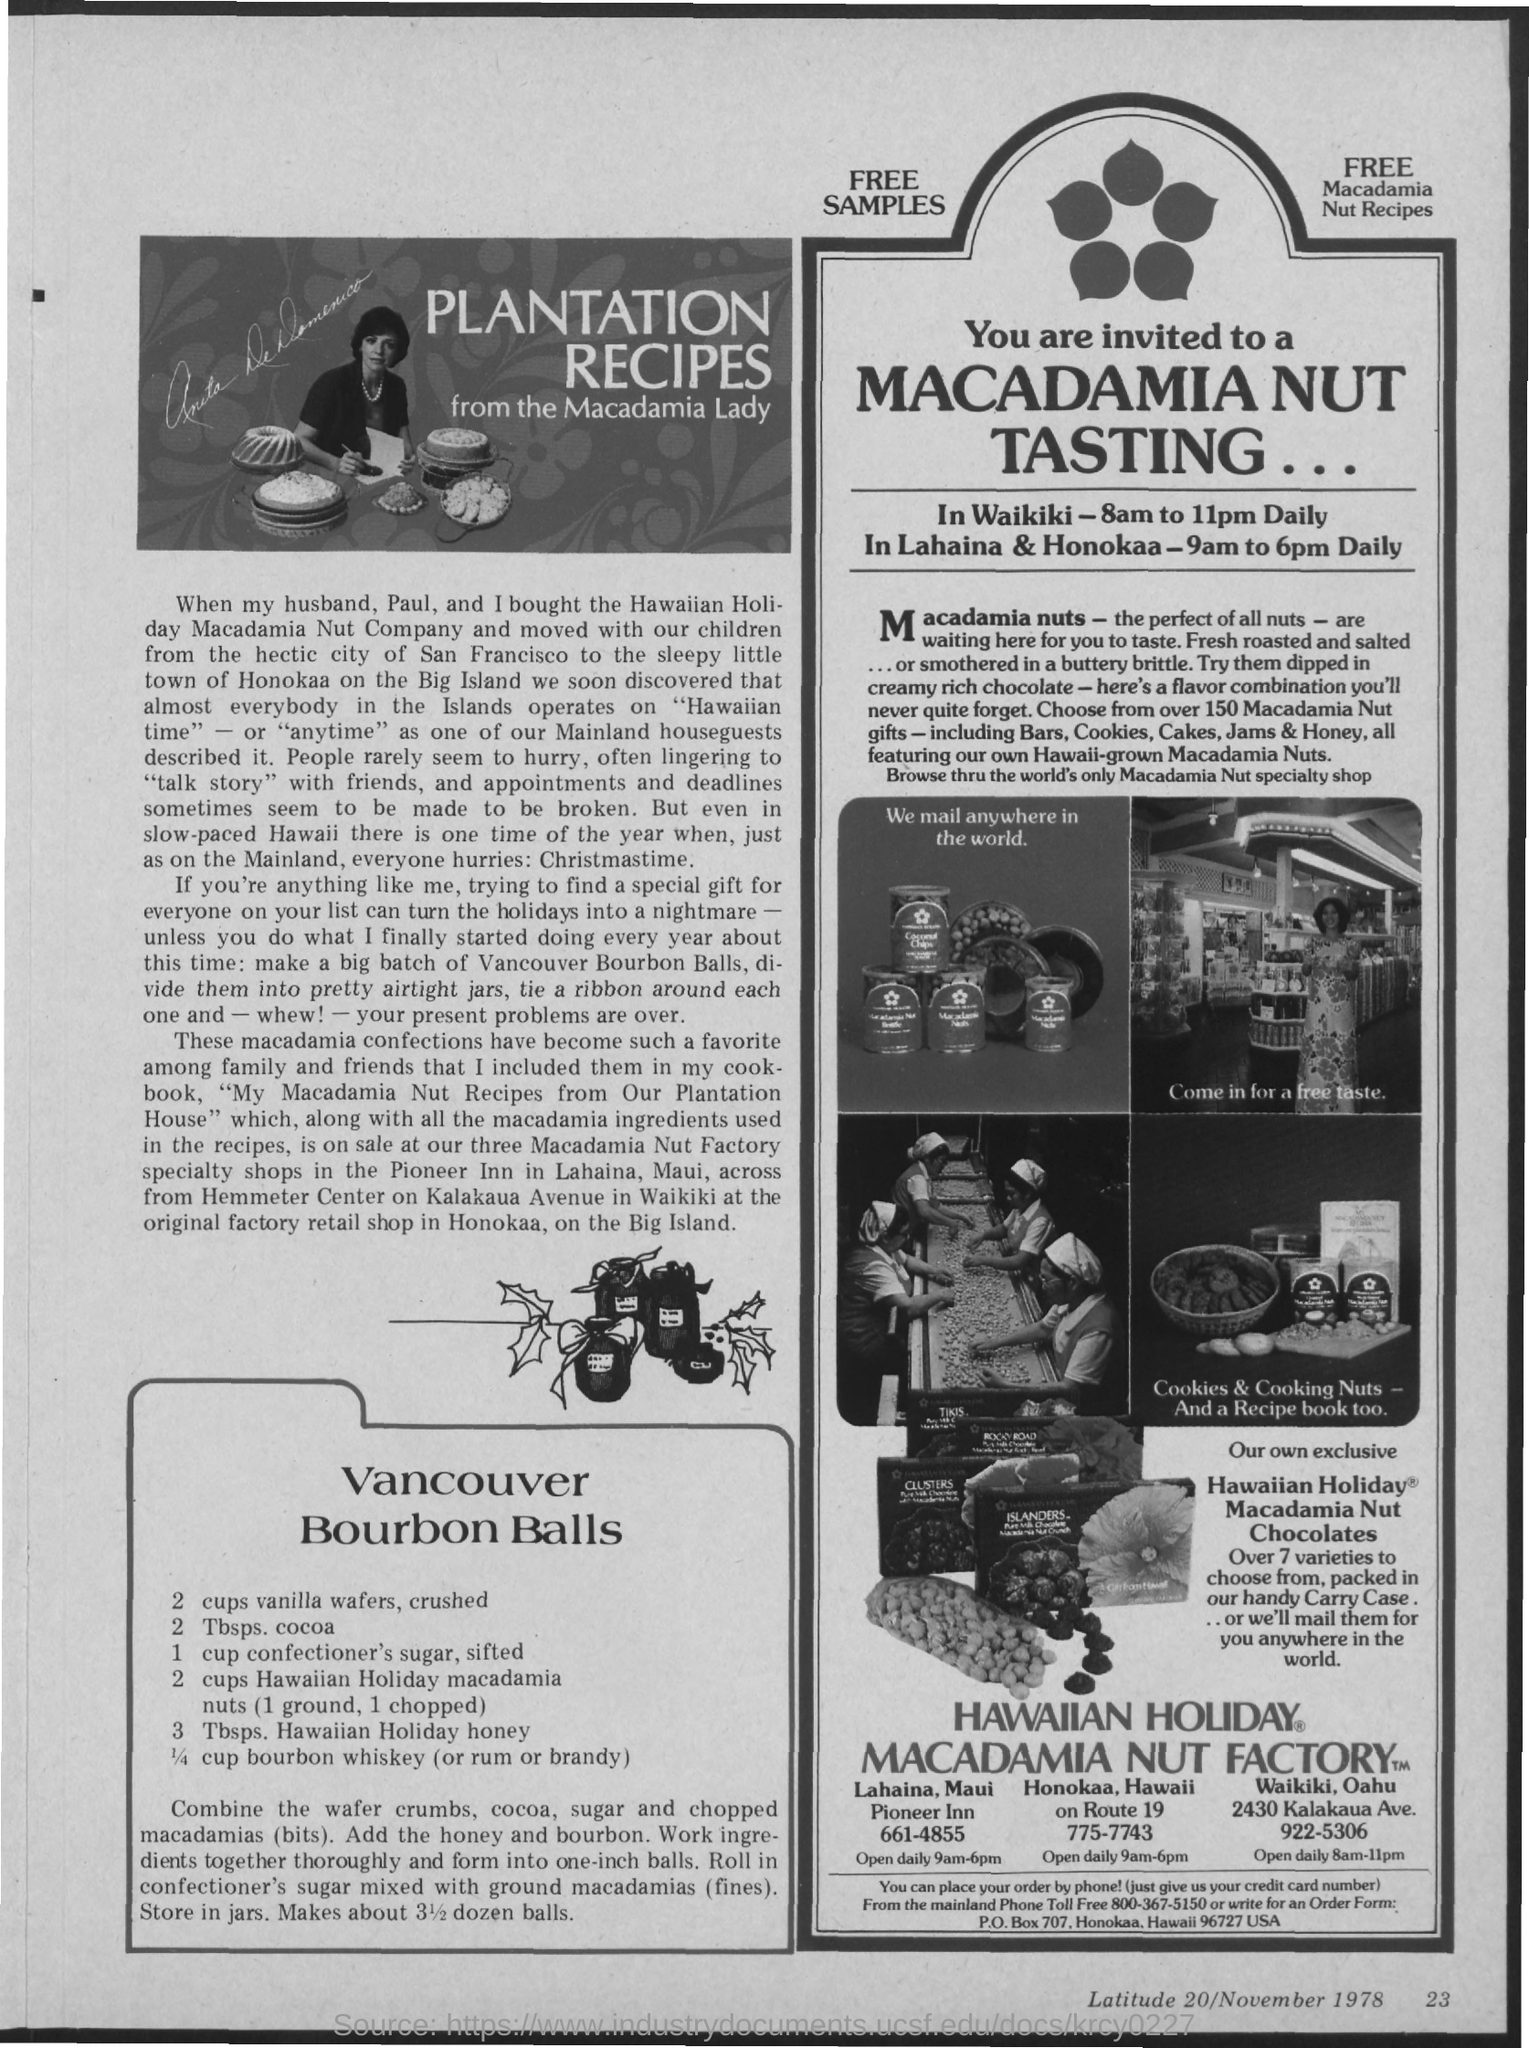Give some essential details in this illustration. The plantation recipes are the property of The Macadamia Lady. 